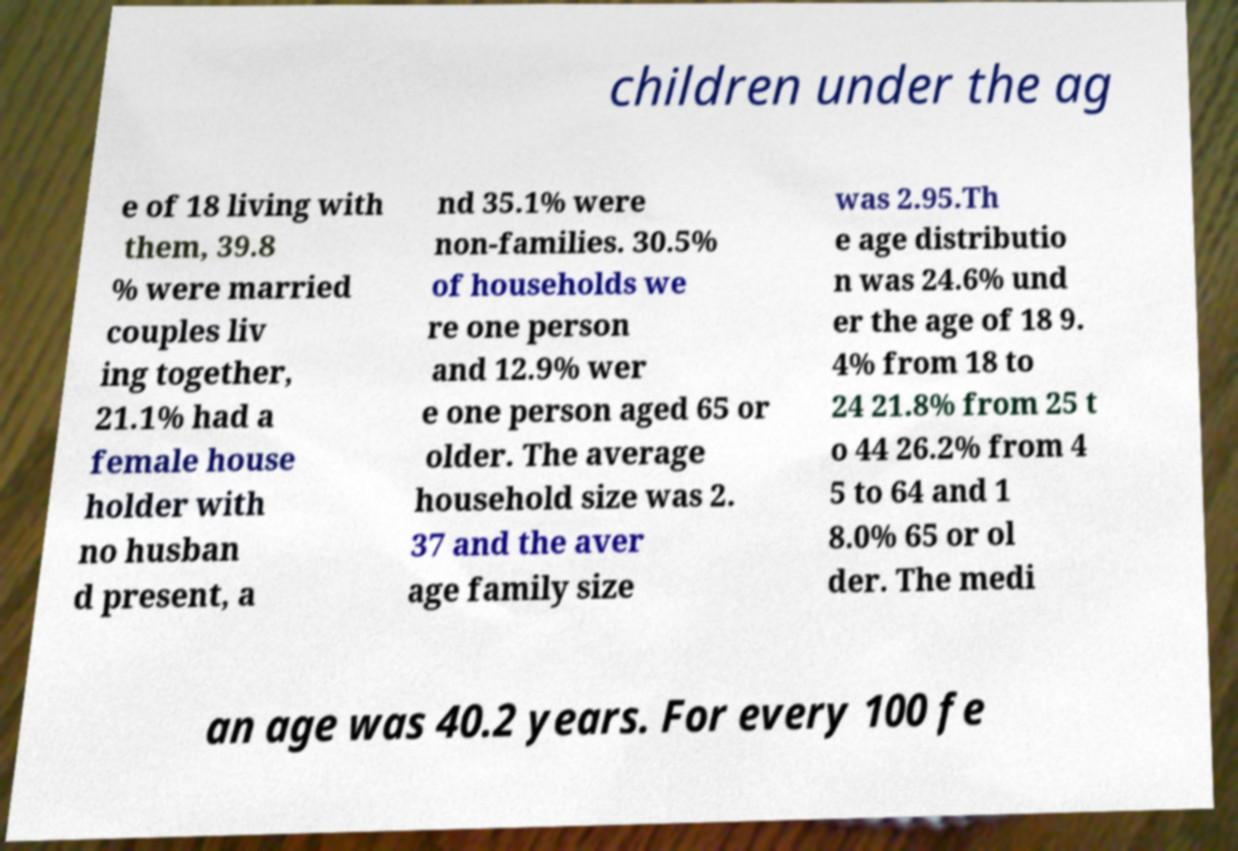Could you assist in decoding the text presented in this image and type it out clearly? children under the ag e of 18 living with them, 39.8 % were married couples liv ing together, 21.1% had a female house holder with no husban d present, a nd 35.1% were non-families. 30.5% of households we re one person and 12.9% wer e one person aged 65 or older. The average household size was 2. 37 and the aver age family size was 2.95.Th e age distributio n was 24.6% und er the age of 18 9. 4% from 18 to 24 21.8% from 25 t o 44 26.2% from 4 5 to 64 and 1 8.0% 65 or ol der. The medi an age was 40.2 years. For every 100 fe 